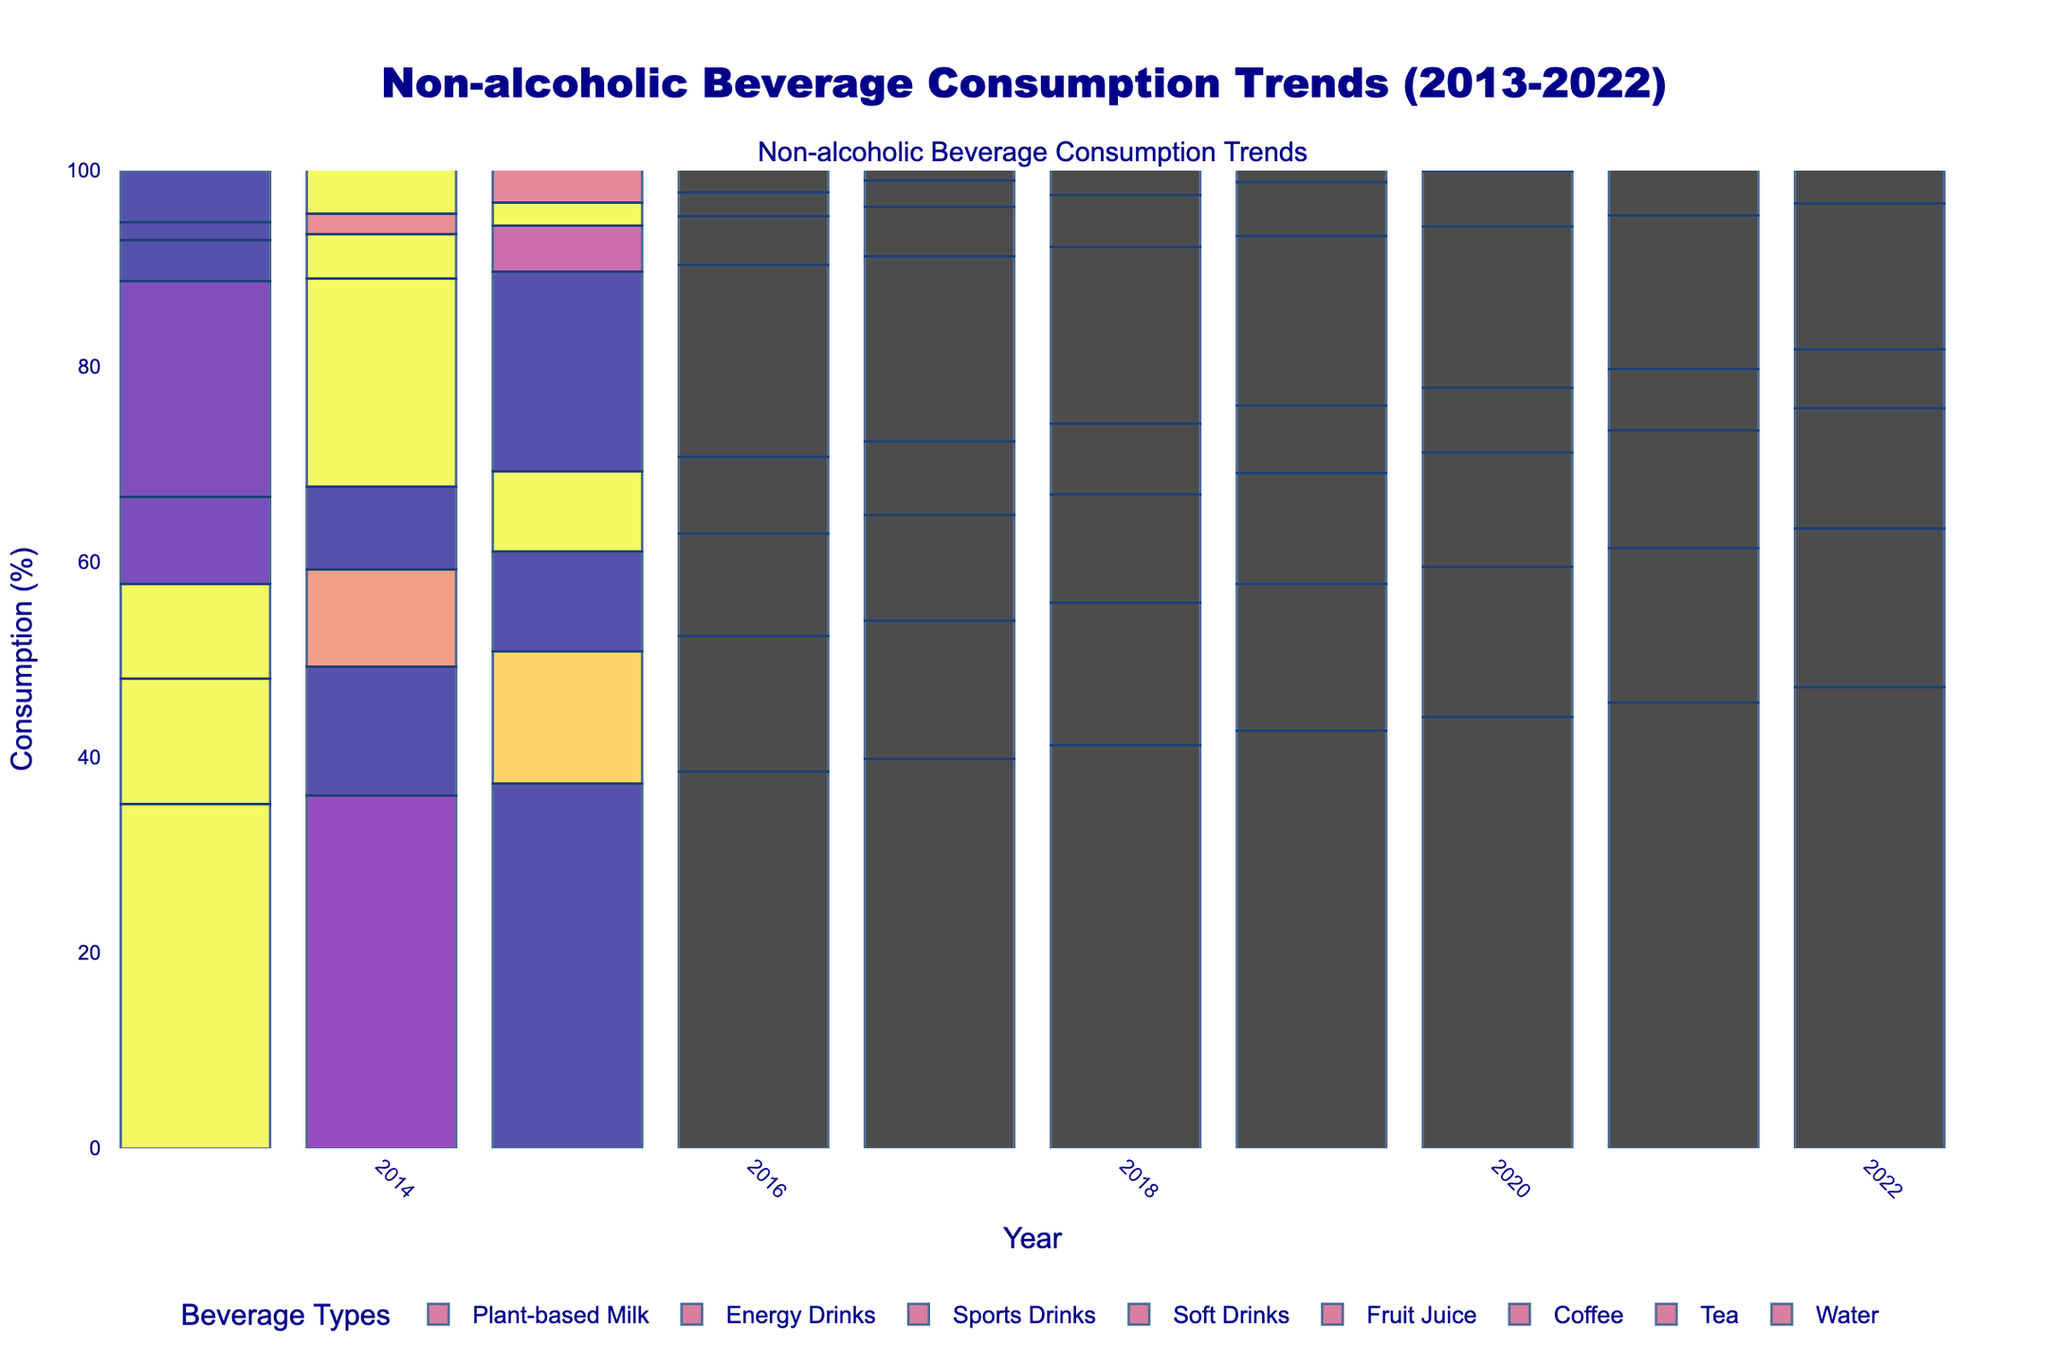Which year had the highest consumption of water? To find the year with the highest water consumption, we locate the tallest bar for the 'Water' category in the plot. The tallest bar corresponds to the year 2022.
Answer: 2022 How did the consumption of Fruit Juice change from 2013 to 2022? We compare the height of the 'Fruit Juice' bars in 2013 and 2022. In 2013, the value is 8.9%, and in 2022, it is 6.0%. This shows a decrease in consumption.
Answer: It decreased Which beverage had the highest percent change in consumption from 2013 to 2022? To determine this, we calculate the percent change for each beverage type. The formula is ((value in 2022 - value in 2013) / value in 2013) * 100. Water increased from 35.2% to 47.2%, which is a 34.1% increase. When compared to other types, this is the highest percent change.
Answer: Water In which year did Tea and Coffee consumption total 22.3%? We add the consumption percentages for Tea and Coffee for each year. The year 2022 has Tea at 16.2% and Coffee at 12.3%, totaling 22.3%.
Answer: 2022 Did the consumption of Energy Drinks ever surpass Sports Drinks? We compare the 'Energy Drinks' and 'Sports Drinks' categories year by year. In every year from 2013 to 2022, 'Sports Drinks' have higher consumption percentages than 'Energy Drinks'.
Answer: No Which beverage had the smallest increase in consumption percentage over the decade? We subtract the 2013 percentage from the 2022 percentage for each beverage. 'Plant-based Milk' increased from 5.3% to 6.9%, which is a 1.6% increase and is the smallest compared to other beverages.
Answer: Plant-based Milk What is the average yearly consumption rate of Soft Drinks over the decade? To find the average, sum the yearly values of Soft Drinks from 2013 to 2022 and divide by the number of years. Sum = (22.1 + 21.3 + 20.5 + 19.7 + 18.9 + 18.1 + 17.3 + 16.5 + 15.7 + 14.9) = 185.0. The average is 185.0 / 10 = 18.5%.
Answer: 18.5% In which year did total consumption of Sports Drinks and Energy Drinks first exceed 10%? We add the yearly percentages of 'Sports Drinks' and 'Energy Drinks' until their sum exceeds 10%. In 2015, the sum is (4.7 + 2.3) = 7.0%; in 2016, the sum is (4.9 + 2.5) = 7.4%; and in 2017, the sum is (5.1 + 2.7) = 7.8%. In 2018, the sum is (5.3 + 2.9) = 8.2%. Only in 2020 does the sum (5.7 + 3.3) exceed 10%, totaling 9.0%.
Answer: 2022 What is the total combined consumption of Plant-based Milk and Fruit Juice in 2019? Add the percentages of 'Plant-based Milk' and 'Fruit Juice' for 2019. Plant-based Milk is 6.3% and Fruit Juice is 6.9%. Total combined consumption = 6.3 + 6.9 = 13.2%.
Answer: 13.2% 